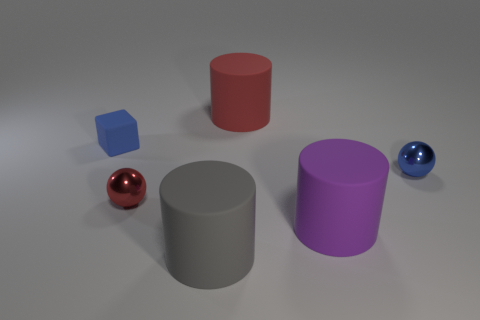What size is the purple cylinder?
Keep it short and to the point. Large. How many shiny spheres are the same color as the tiny block?
Your answer should be compact. 1. There is a purple cylinder in front of the small metallic ball that is right of the red object that is in front of the blue block; how big is it?
Ensure brevity in your answer.  Large. The gray object that is the same shape as the big purple thing is what size?
Offer a terse response. Large. How many large objects are either gray matte cylinders or yellow metal spheres?
Offer a very short reply. 1. Are the tiny blue thing that is to the right of the large purple rubber thing and the block that is on the left side of the gray thing made of the same material?
Your response must be concise. No. There is a small sphere that is right of the big red rubber cylinder; what is its material?
Offer a very short reply. Metal. What number of matte objects are either big red cubes or blue balls?
Your answer should be very brief. 0. There is a small metallic object behind the metallic object on the left side of the big gray thing; what color is it?
Give a very brief answer. Blue. Is the material of the small red ball the same as the object left of the red sphere?
Provide a short and direct response. No. 